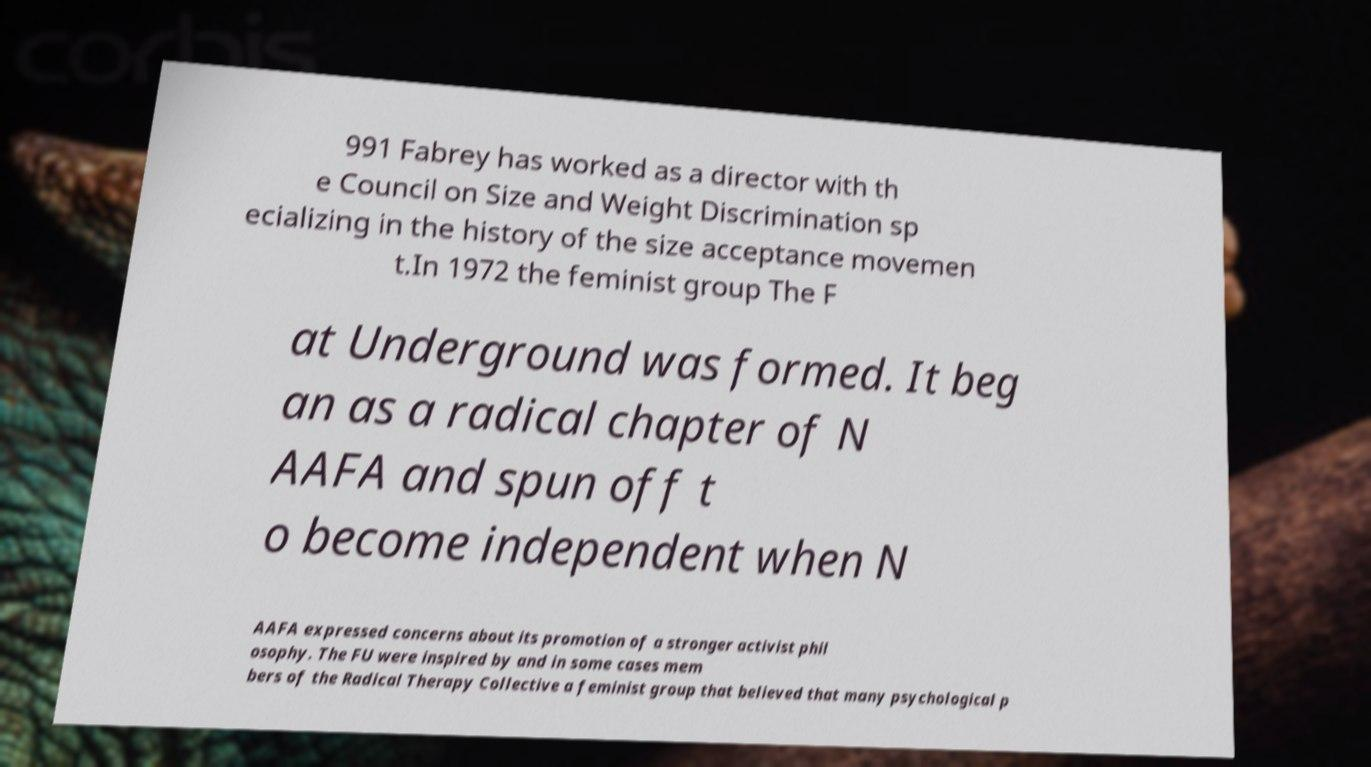Can you read and provide the text displayed in the image?This photo seems to have some interesting text. Can you extract and type it out for me? 991 Fabrey has worked as a director with th e Council on Size and Weight Discrimination sp ecializing in the history of the size acceptance movemen t.In 1972 the feminist group The F at Underground was formed. It beg an as a radical chapter of N AAFA and spun off t o become independent when N AAFA expressed concerns about its promotion of a stronger activist phil osophy. The FU were inspired by and in some cases mem bers of the Radical Therapy Collective a feminist group that believed that many psychological p 